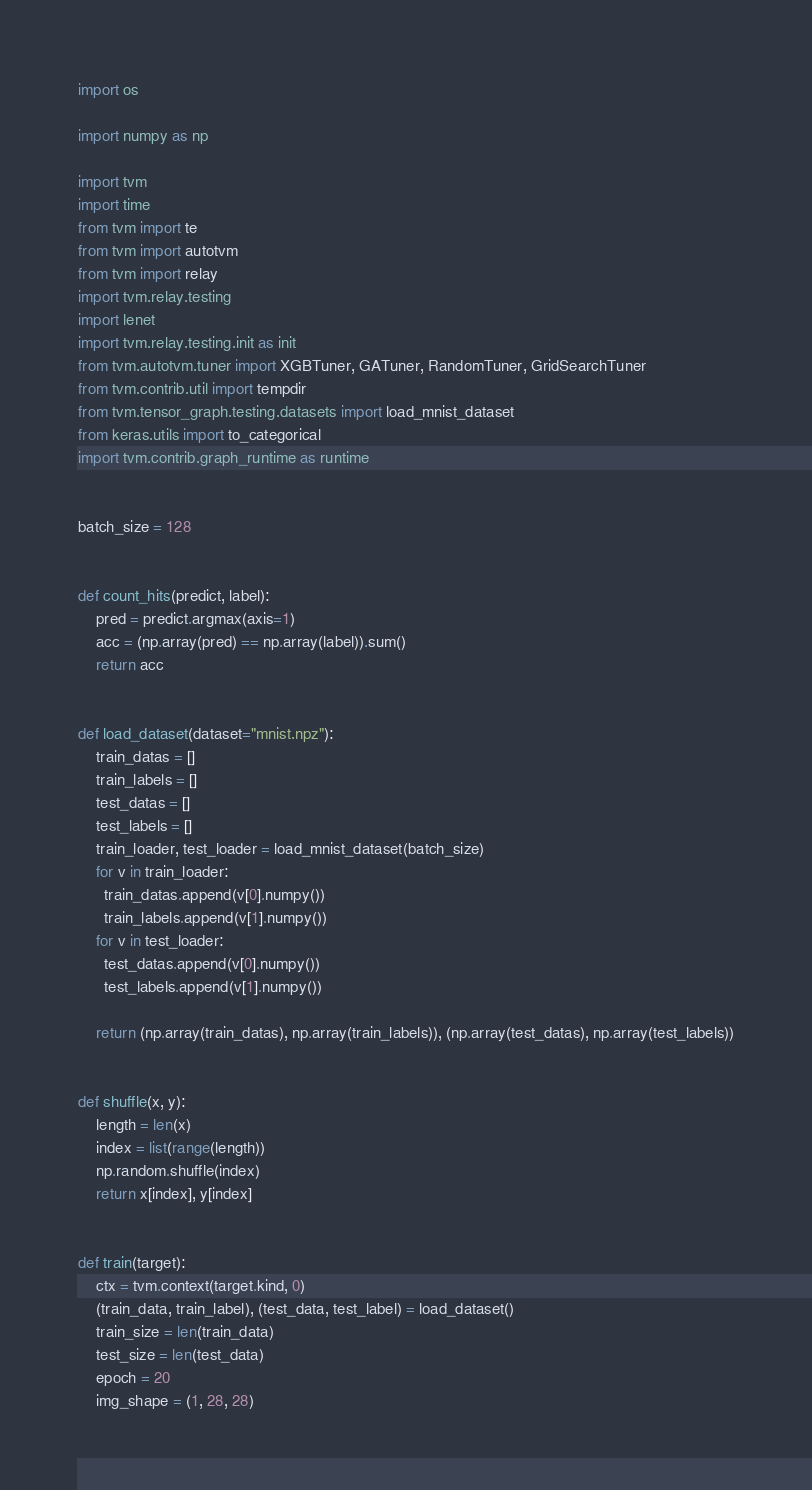<code> <loc_0><loc_0><loc_500><loc_500><_Python_>import os

import numpy as np

import tvm
import time
from tvm import te
from tvm import autotvm
from tvm import relay
import tvm.relay.testing
import lenet
import tvm.relay.testing.init as init
from tvm.autotvm.tuner import XGBTuner, GATuner, RandomTuner, GridSearchTuner
from tvm.contrib.util import tempdir
from tvm.tensor_graph.testing.datasets import load_mnist_dataset
from keras.utils import to_categorical
import tvm.contrib.graph_runtime as runtime


batch_size = 128


def count_hits(predict, label):
    pred = predict.argmax(axis=1)
    acc = (np.array(pred) == np.array(label)).sum()
    return acc


def load_dataset(dataset="mnist.npz"):
    train_datas = []
    train_labels = []
    test_datas = []
    test_labels = []
    train_loader, test_loader = load_mnist_dataset(batch_size)
    for v in train_loader:
      train_datas.append(v[0].numpy())
      train_labels.append(v[1].numpy())
    for v in test_loader:
      test_datas.append(v[0].numpy())
      test_labels.append(v[1].numpy())

    return (np.array(train_datas), np.array(train_labels)), (np.array(test_datas), np.array(test_labels))


def shuffle(x, y):
    length = len(x)
    index = list(range(length))
    np.random.shuffle(index)
    return x[index], y[index]


def train(target):
    ctx = tvm.context(target.kind, 0)
    (train_data, train_label), (test_data, test_label) = load_dataset()
    train_size = len(train_data)
    test_size = len(test_data)
    epoch = 20
    img_shape = (1, 28, 28)</code> 